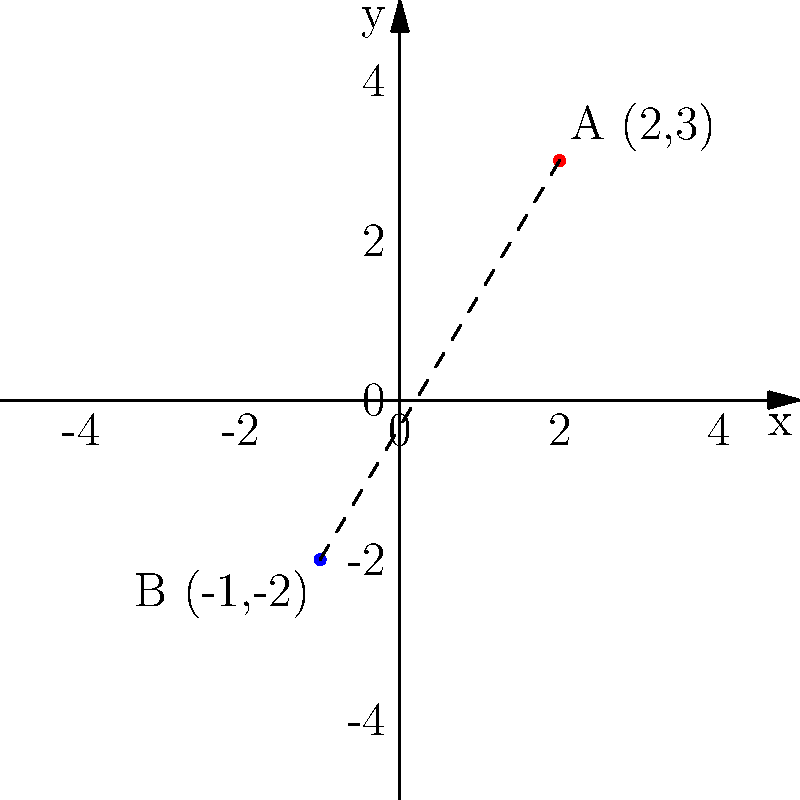On an anatomical coordinate system, two sports-related injury locations are marked: point A (2,3) representing a shoulder injury, and point B (-1,-2) representing a knee injury. Calculate the distance between these two injury locations to assess the potential severity of the athlete's condition. To calculate the distance between two points on a coordinate system, we use the distance formula derived from the Pythagorean theorem:

$$ d = \sqrt{(x_2 - x_1)^2 + (y_2 - y_1)^2} $$

Where $(x_1, y_1)$ are the coordinates of the first point and $(x_2, y_2)$ are the coordinates of the second point.

Step 1: Identify the coordinates
Point A (shoulder injury): $(x_1, y_1) = (2, 3)$
Point B (knee injury): $(x_2, y_2) = (-1, -2)$

Step 2: Plug the coordinates into the distance formula
$$ d = \sqrt{(-1 - 2)^2 + (-2 - 3)^2} $$

Step 3: Simplify the expressions inside the parentheses
$$ d = \sqrt{(-3)^2 + (-5)^2} $$

Step 4: Calculate the squares
$$ d = \sqrt{9 + 25} $$

Step 5: Add the values under the square root
$$ d = \sqrt{34} $$

Step 6: Simplify the square root (if possible)
In this case, $\sqrt{34}$ cannot be simplified further.

Therefore, the distance between the two injury locations is $\sqrt{34}$ units on the anatomical coordinate system.
Answer: $\sqrt{34}$ units 